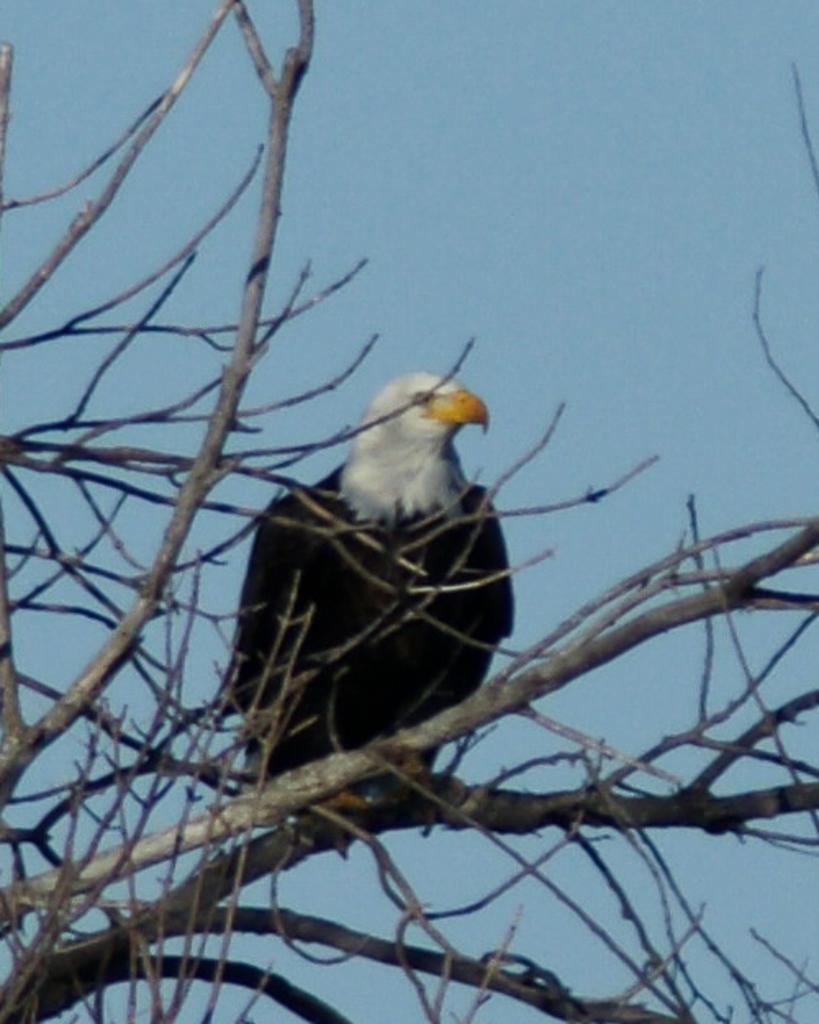How would you summarize this image in a sentence or two? As we can see in the image there is a black color bird standing on dry tree. At the top there is sky. 